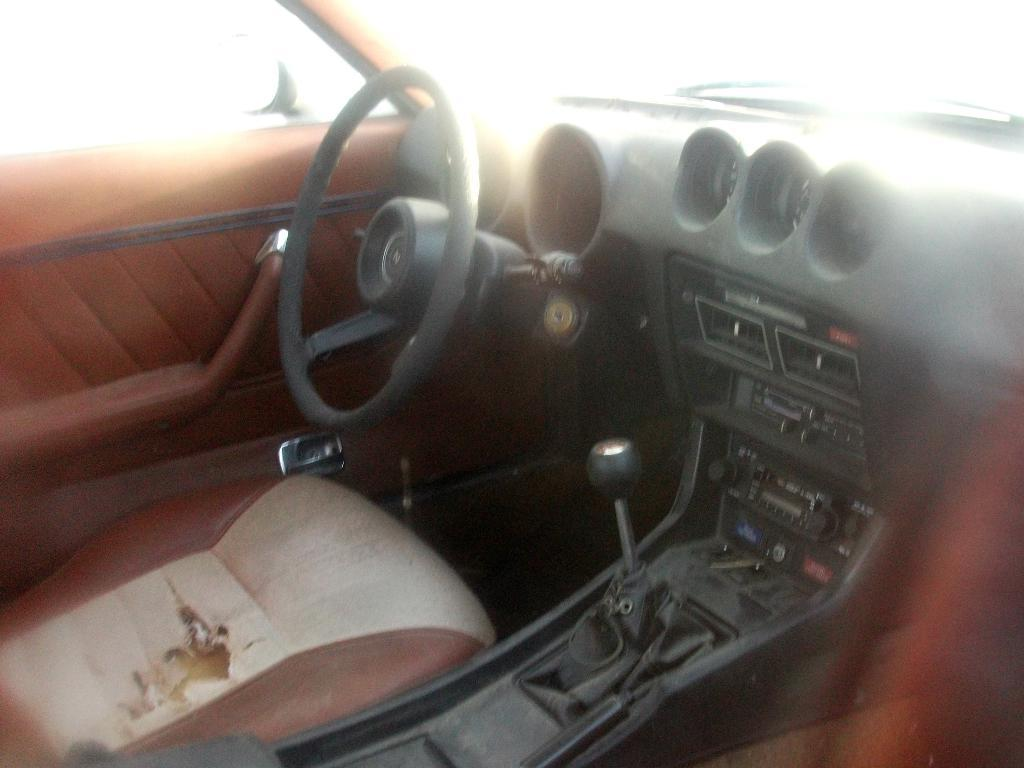What is the setting of the image? The image is captured from inside a car. What can be seen in the driver's area of the car? There is a steering wheel, a speedometer, and a gear in the image. What type of spark can be seen coming from the gear in the image? There is no spark coming from the gear in the image. The gear is a part of the car's transmission system and does not produce sparks. 